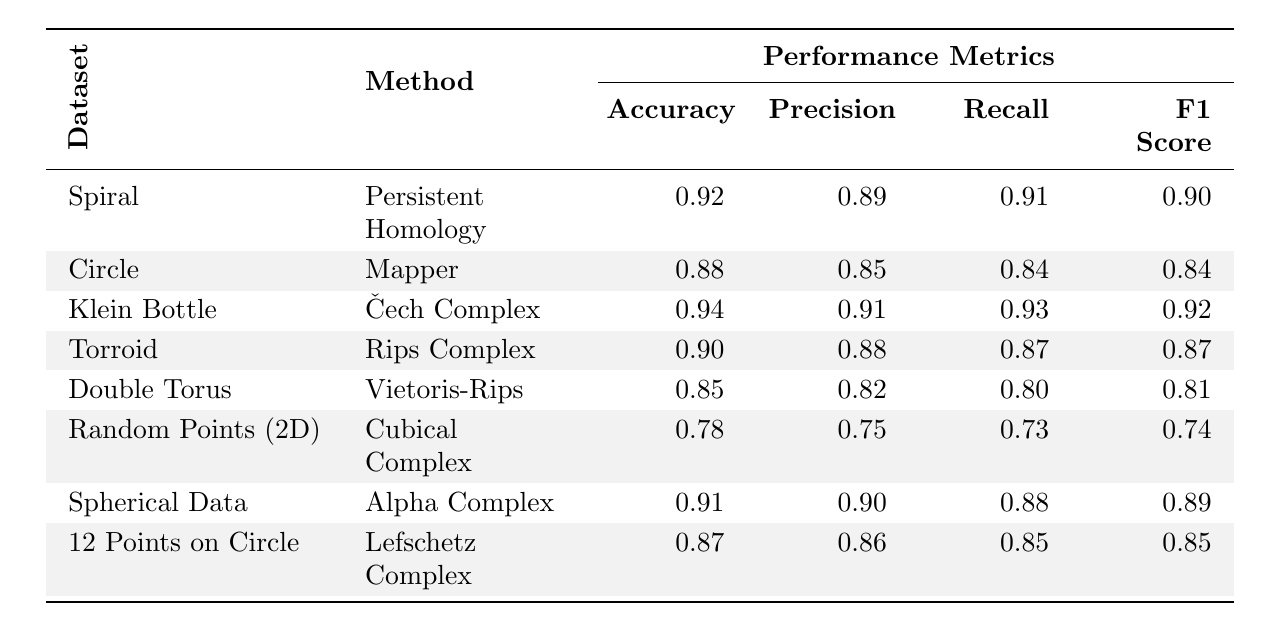What is the accuracy of the Mapper method on the Circle dataset? The table shows that the accuracy for the Mapper method on the Circle dataset is listed directly under the appropriate columns. Specifically, it reads 0.88.
Answer: 0.88 Which method achieved the highest recall? To find this, we compare the recall values across all methods. The highest recall is found for the Čech Complex applied to the Klein Bottle with a value of 0.93.
Answer: 0.93 What is the F1 score of the Cubical Complex for Random Points (2D)? The F1 score for the Cubical Complex method applied to Random Points (2D) is recorded in the F1 Score column, showing a value of 0.74.
Answer: 0.74 Is the precision of the Rips Complex higher than that of the Mapper method? We need to compare the precision values for both methods. The precision for the Rips Complex is 0.88, while the precision for the Mapper is 0.85, indicating that Rips Complex has a higher precision.
Answer: Yes What is the average accuracy across all methods? We sum the accuracy values: (0.92 + 0.88 + 0.94 + 0.90 + 0.85 + 0.78 + 0.91 + 0.87) = 7.15. Then, divide by the number of methods (8) to get the average: 7.15 / 8 = 0.89375.
Answer: 0.89375 Which dataset has the lowest F1 score, and what is its value? By reviewing the F1 Score column, we identify that the dataset with the lowest F1 score is Random Points (2D) with a value of 0.74.
Answer: Random Points (2D), 0.74 What is the difference in accuracy between the highest and lowest-performing methods? The highest accuracy is 0.94 (Čech Complex on Klein Bottle) and the lowest accuracy is 0.78 (Cubical Complex on Random Points (2D)). The difference is calculated as 0.94 - 0.78 = 0.16.
Answer: 0.16 Did the Alpha Complex perform better or worse than the Vietoris-Rips method in terms of recall? The recall for the Alpha Complex is 0.88, while the recall for the Vietoris-Rips is 0.80. Since 0.88 > 0.80, the Alpha Complex performed better in this regard.
Answer: Better What is the average precision for datasets that performed better than 0.90 in accuracy? First, identify methods with accuracy greater than 0.90: Persistent Homology (0.92), Čech Complex (0.94), and Alpha Complex (0.91). The precision values are 0.89, 0.91, and 0.90 respectively, which sum to 2.70. The average precision is then 2.70 / 3 = 0.90.
Answer: 0.90 Which method had the best overall performance? To determine the best overall performance, we can look at the highest accuracy combined with other metrics. The Čech Complex on the Klein Bottle shows the highest accuracy (0.94), precision (0.91), recall (0.93), and F1 score (0.92) compared to others.
Answer: Čech Complex on Klein Bottle 